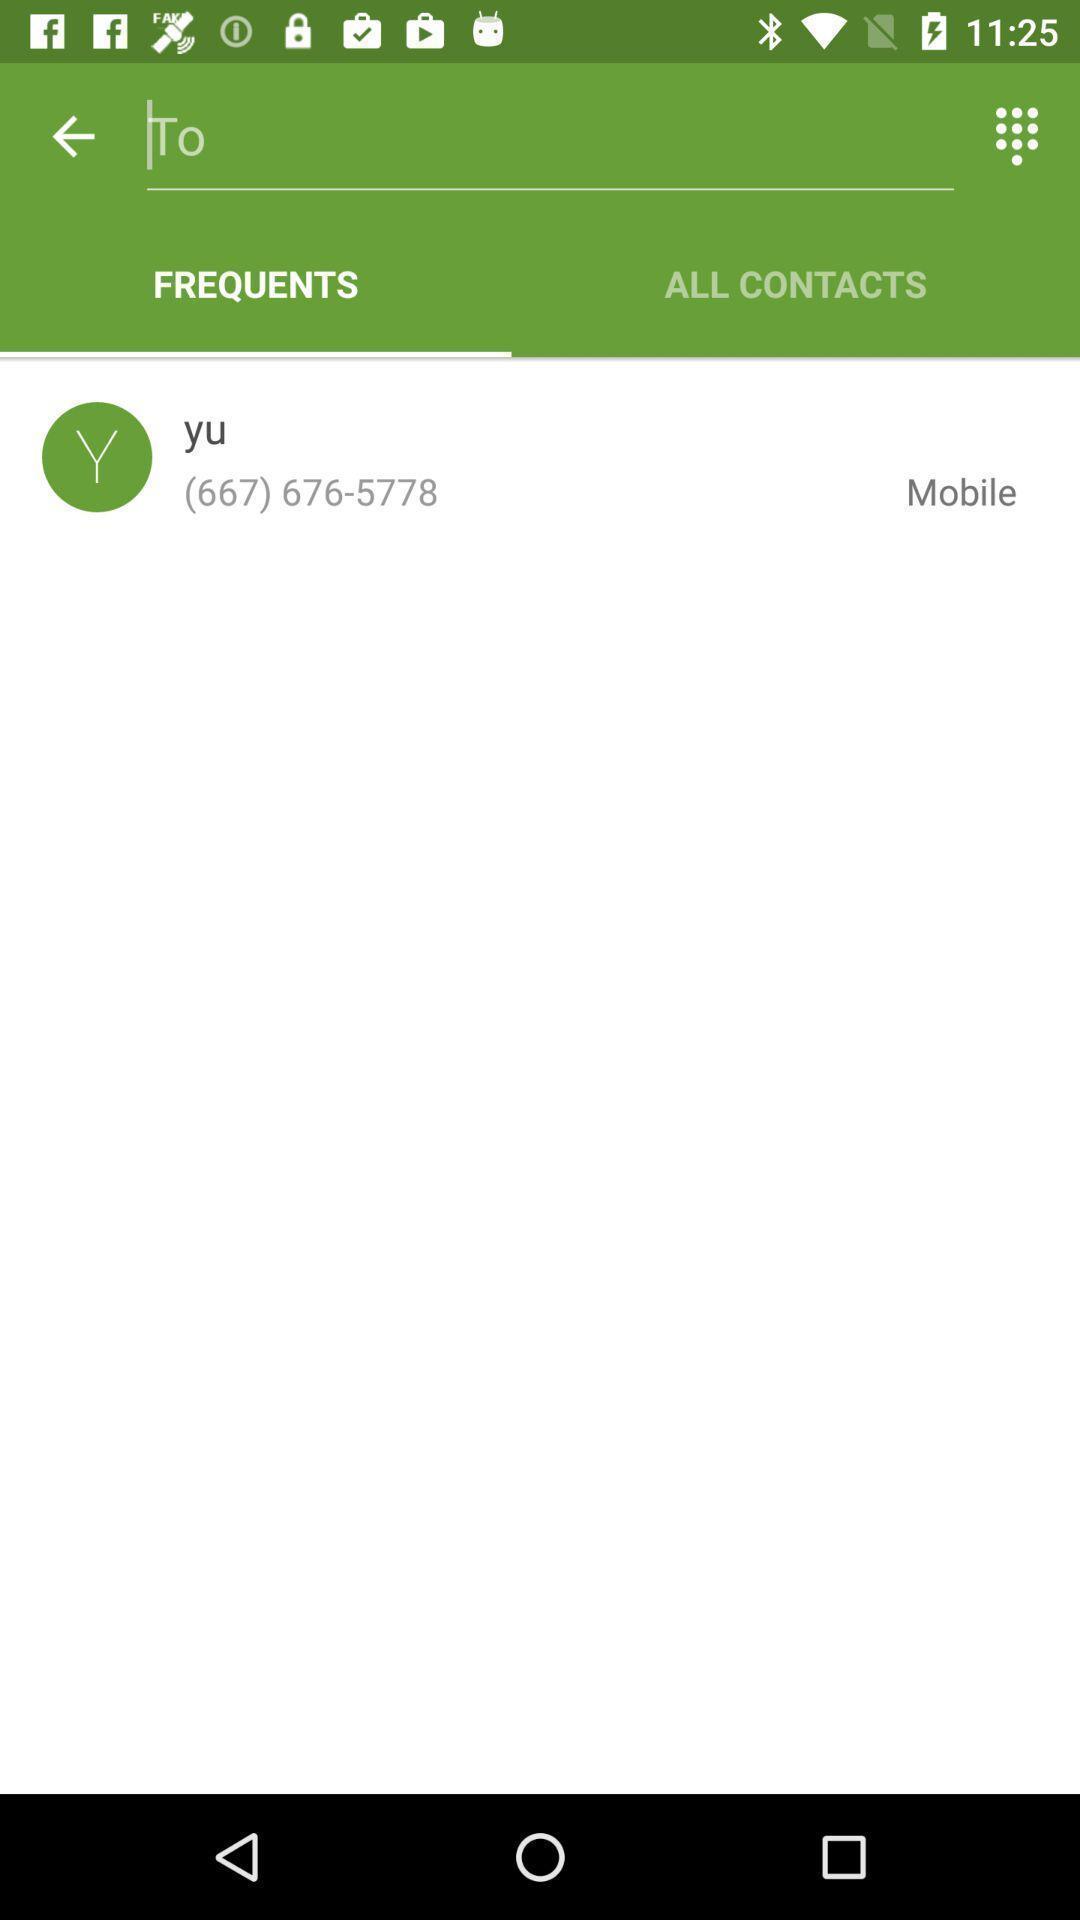Tell me about the visual elements in this screen capture. Screen showing frequently used contacts page. 